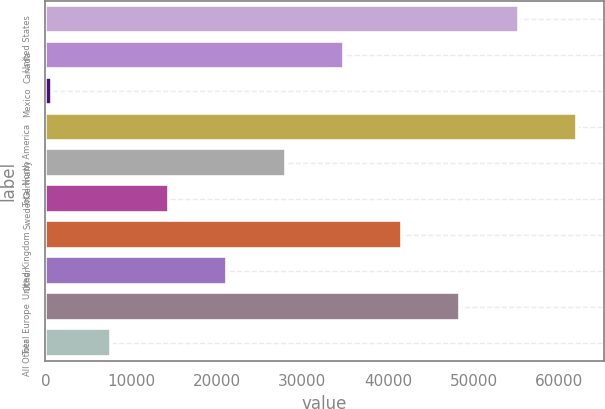Convert chart to OTSL. <chart><loc_0><loc_0><loc_500><loc_500><bar_chart><fcel>United States<fcel>Canada<fcel>Mexico<fcel>Total North America<fcel>Germany<fcel>Sweden<fcel>United Kingdom<fcel>Other<fcel>Total Europe<fcel>All Other<nl><fcel>55263<fcel>34842<fcel>807<fcel>62070<fcel>28035<fcel>14421<fcel>41649<fcel>21228<fcel>48456<fcel>7614<nl></chart> 